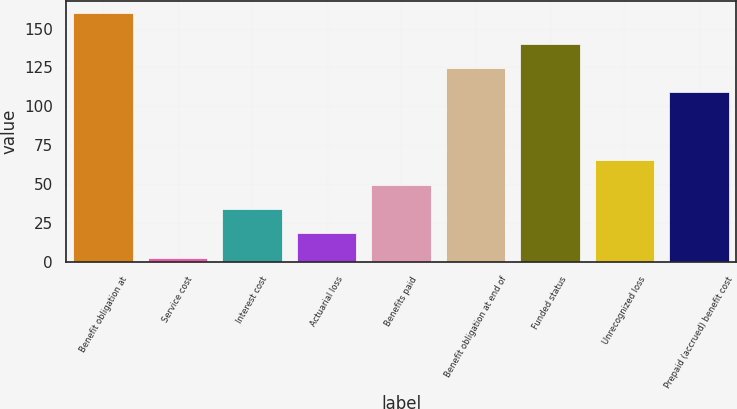<chart> <loc_0><loc_0><loc_500><loc_500><bar_chart><fcel>Benefit obligation at<fcel>Service cost<fcel>Interest cost<fcel>Actuarial loss<fcel>Benefits paid<fcel>Benefit obligation at end of<fcel>Funded status<fcel>Unrecognized loss<fcel>Prepaid (accrued) benefit cost<nl><fcel>159.8<fcel>2.5<fcel>33.96<fcel>18.23<fcel>49.69<fcel>124.63<fcel>140.36<fcel>65.42<fcel>108.9<nl></chart> 